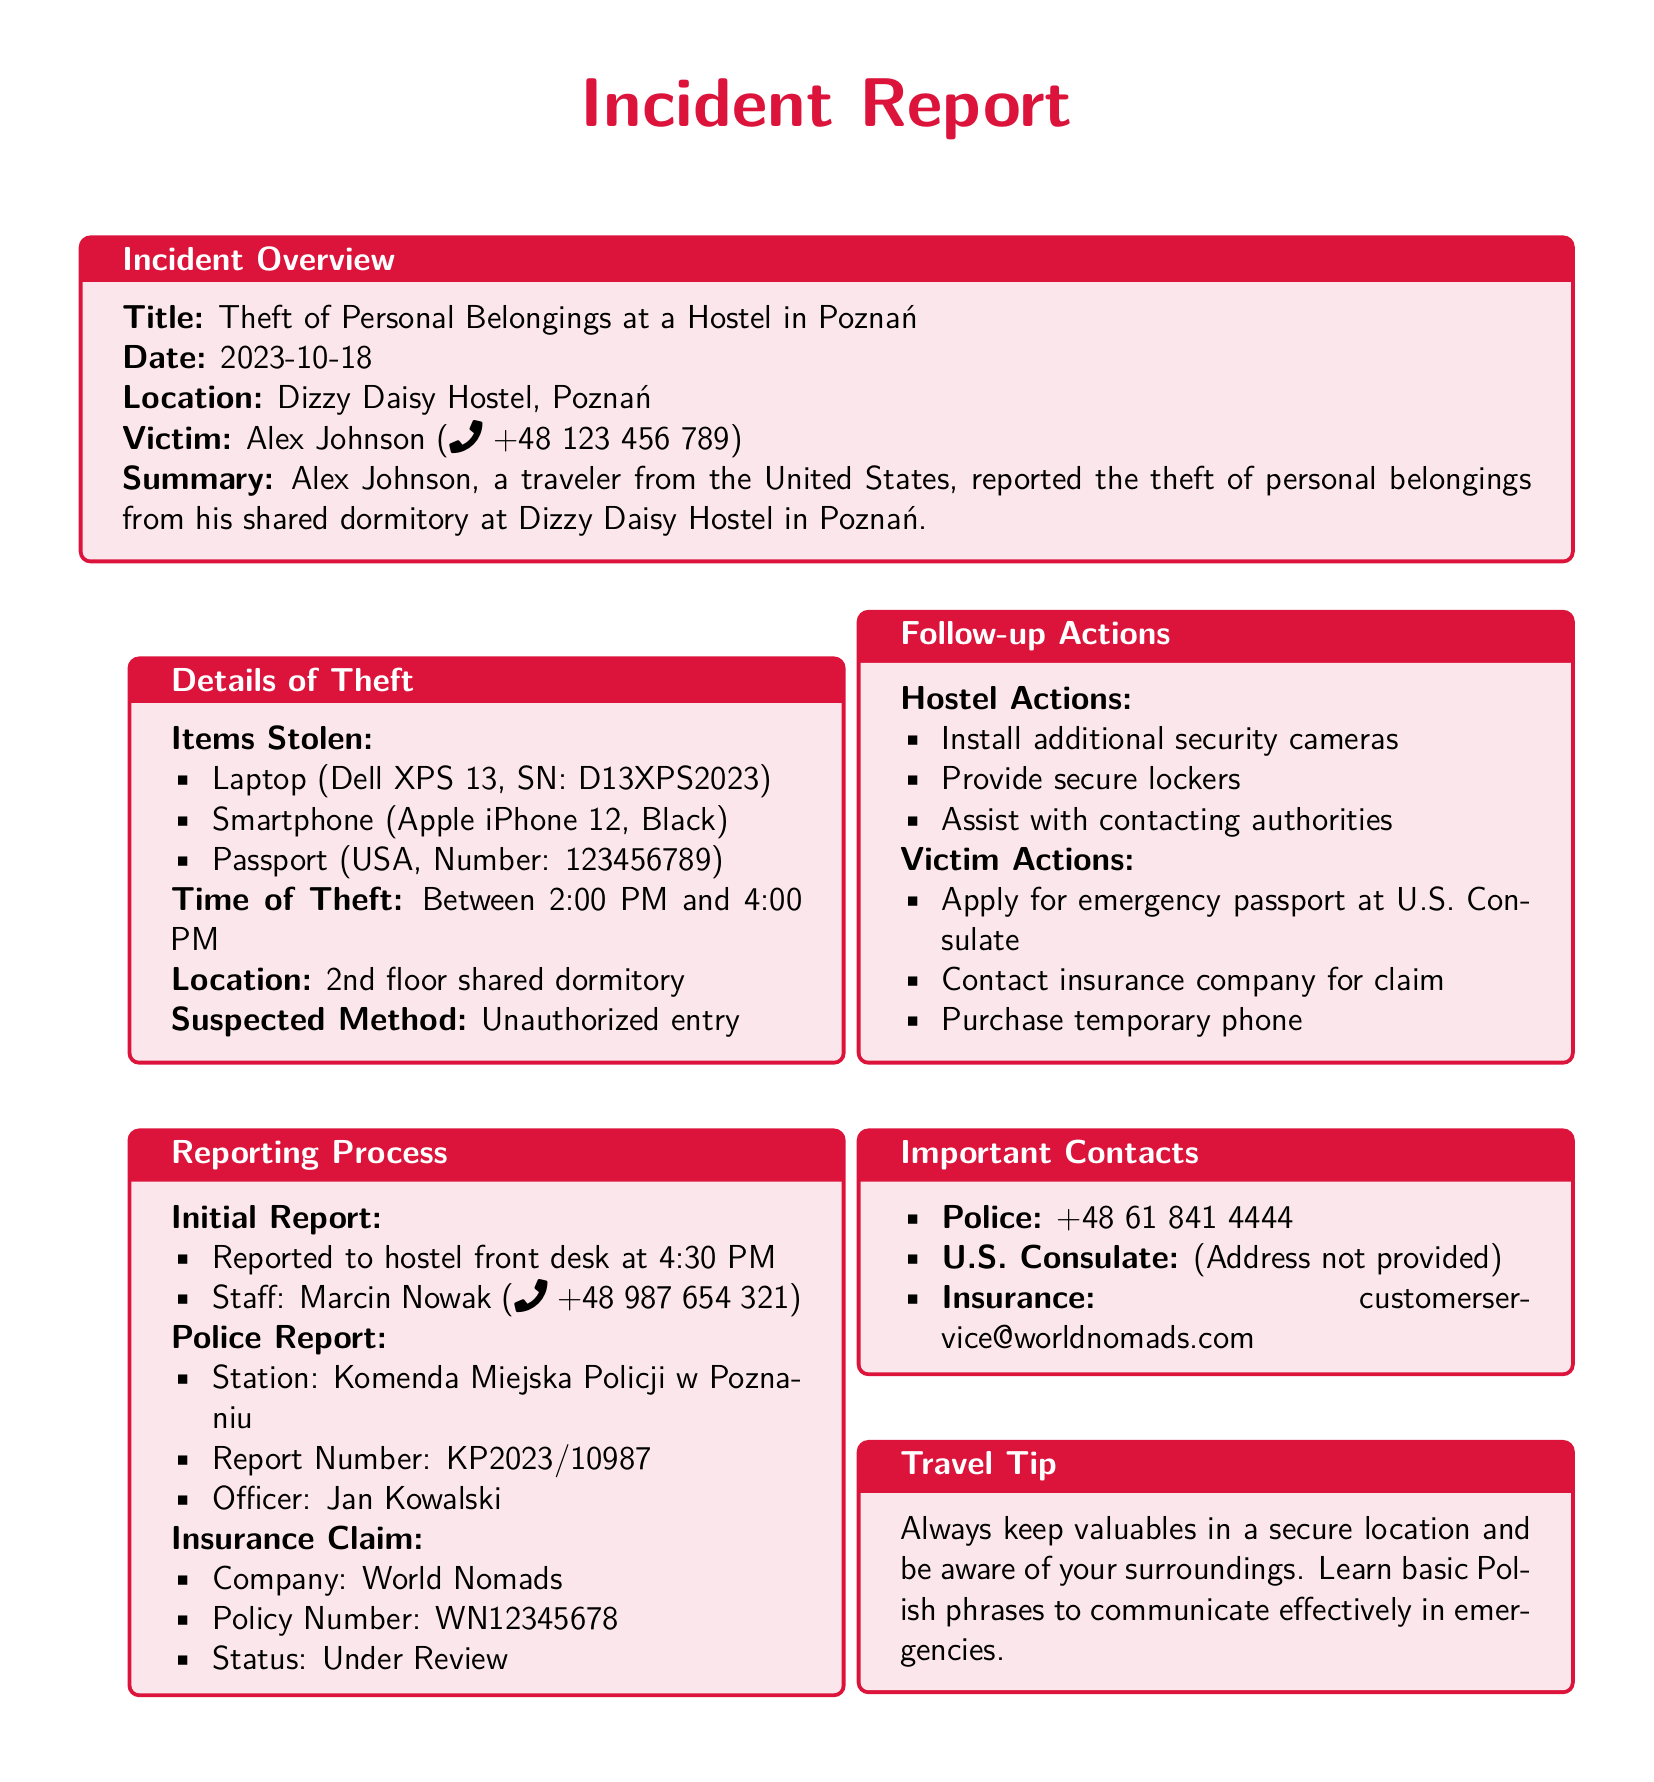What is the date of the incident? The date of the incident is stated in the overview section of the document.
Answer: 2023-10-18 Who is the victim? The victim's name is identified at the beginning of the incident overview.
Answer: Alex Johnson What items were stolen? The items stolen are listed under the details of the theft section in the document.
Answer: Laptop, Smartphone, Passport What is the report number for the police report? The report number can be found in the police report section of the document.
Answer: KP2023/10987 Which company is handling the insurance claim? The insurance company's name is mentioned in the insurance claim section.
Answer: World Nomads Why did the victim contact the U.S. Consulate? The document states the victim's actions after the theft, requiring emergency assistance.
Answer: Apply for emergency passport What follow-up action involves contacting authorities? The hostel's efforts to assist the victim include a specific follow-up action mentioned in the document.
Answer: Assist with contacting authorities What time did the theft occur? The time of the theft is indicated in the details of theft section.
Answer: Between 2:00 PM and 4:00 PM What was the victim's temporary solution for communication? This information is found under the victim's actions following the theft.
Answer: Purchase temporary phone 